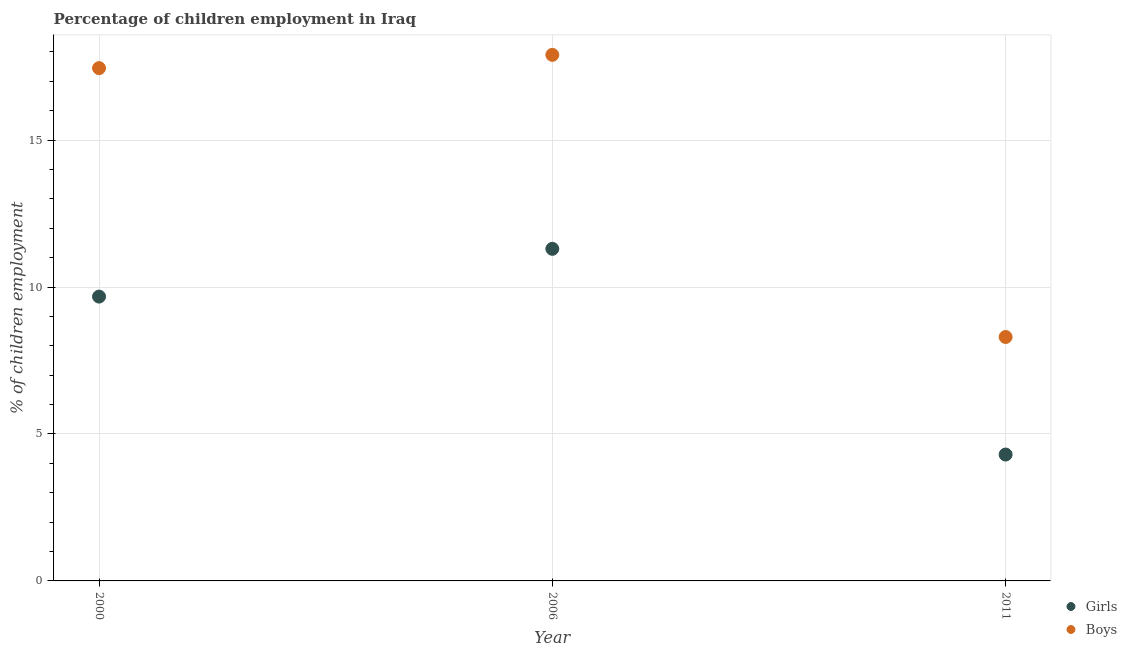How many different coloured dotlines are there?
Ensure brevity in your answer.  2. Is the number of dotlines equal to the number of legend labels?
Ensure brevity in your answer.  Yes. What is the percentage of employed boys in 2000?
Your answer should be very brief. 17.45. Across all years, what is the maximum percentage of employed boys?
Ensure brevity in your answer.  17.9. Across all years, what is the minimum percentage of employed girls?
Offer a terse response. 4.3. In which year was the percentage of employed girls minimum?
Offer a terse response. 2011. What is the total percentage of employed boys in the graph?
Ensure brevity in your answer.  43.65. What is the difference between the percentage of employed boys in 2000 and that in 2006?
Ensure brevity in your answer.  -0.45. What is the difference between the percentage of employed boys in 2006 and the percentage of employed girls in 2000?
Offer a terse response. 8.23. What is the average percentage of employed girls per year?
Your answer should be very brief. 8.42. In the year 2011, what is the difference between the percentage of employed girls and percentage of employed boys?
Give a very brief answer. -4. In how many years, is the percentage of employed boys greater than 4 %?
Provide a short and direct response. 3. What is the ratio of the percentage of employed girls in 2006 to that in 2011?
Ensure brevity in your answer.  2.63. Is the percentage of employed girls in 2006 less than that in 2011?
Make the answer very short. No. What is the difference between the highest and the second highest percentage of employed boys?
Make the answer very short. 0.45. What is the difference between the highest and the lowest percentage of employed girls?
Ensure brevity in your answer.  7. In how many years, is the percentage of employed girls greater than the average percentage of employed girls taken over all years?
Offer a terse response. 2. Is the percentage of employed boys strictly greater than the percentage of employed girls over the years?
Your answer should be compact. Yes. How many dotlines are there?
Offer a terse response. 2. Does the graph contain any zero values?
Offer a terse response. No. How are the legend labels stacked?
Keep it short and to the point. Vertical. What is the title of the graph?
Provide a short and direct response. Percentage of children employment in Iraq. What is the label or title of the Y-axis?
Provide a succinct answer. % of children employment. What is the % of children employment of Girls in 2000?
Provide a short and direct response. 9.67. What is the % of children employment of Boys in 2000?
Ensure brevity in your answer.  17.45. What is the % of children employment of Girls in 2006?
Make the answer very short. 11.3. What is the % of children employment of Boys in 2011?
Provide a short and direct response. 8.3. Across all years, what is the minimum % of children employment in Girls?
Give a very brief answer. 4.3. What is the total % of children employment of Girls in the graph?
Keep it short and to the point. 25.27. What is the total % of children employment in Boys in the graph?
Your response must be concise. 43.65. What is the difference between the % of children employment of Girls in 2000 and that in 2006?
Provide a succinct answer. -1.63. What is the difference between the % of children employment of Boys in 2000 and that in 2006?
Provide a short and direct response. -0.45. What is the difference between the % of children employment in Girls in 2000 and that in 2011?
Give a very brief answer. 5.37. What is the difference between the % of children employment of Boys in 2000 and that in 2011?
Keep it short and to the point. 9.15. What is the difference between the % of children employment of Girls in 2006 and that in 2011?
Provide a succinct answer. 7. What is the difference between the % of children employment in Girls in 2000 and the % of children employment in Boys in 2006?
Offer a terse response. -8.23. What is the difference between the % of children employment of Girls in 2000 and the % of children employment of Boys in 2011?
Give a very brief answer. 1.37. What is the difference between the % of children employment of Girls in 2006 and the % of children employment of Boys in 2011?
Provide a succinct answer. 3. What is the average % of children employment of Girls per year?
Offer a terse response. 8.43. What is the average % of children employment of Boys per year?
Offer a terse response. 14.55. In the year 2000, what is the difference between the % of children employment in Girls and % of children employment in Boys?
Offer a very short reply. -7.77. In the year 2011, what is the difference between the % of children employment in Girls and % of children employment in Boys?
Give a very brief answer. -4. What is the ratio of the % of children employment of Girls in 2000 to that in 2006?
Offer a very short reply. 0.86. What is the ratio of the % of children employment of Boys in 2000 to that in 2006?
Your answer should be compact. 0.97. What is the ratio of the % of children employment in Girls in 2000 to that in 2011?
Your answer should be compact. 2.25. What is the ratio of the % of children employment of Boys in 2000 to that in 2011?
Ensure brevity in your answer.  2.1. What is the ratio of the % of children employment of Girls in 2006 to that in 2011?
Your answer should be compact. 2.63. What is the ratio of the % of children employment in Boys in 2006 to that in 2011?
Your response must be concise. 2.16. What is the difference between the highest and the second highest % of children employment of Girls?
Keep it short and to the point. 1.63. What is the difference between the highest and the second highest % of children employment in Boys?
Make the answer very short. 0.45. What is the difference between the highest and the lowest % of children employment of Girls?
Your response must be concise. 7. What is the difference between the highest and the lowest % of children employment of Boys?
Offer a very short reply. 9.6. 